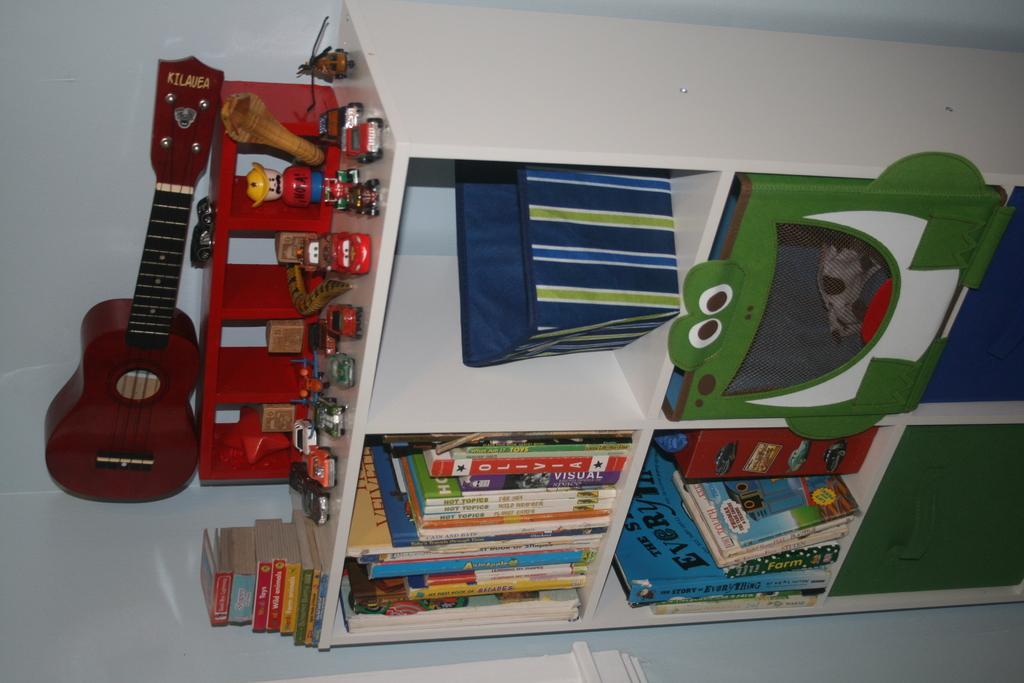How would you summarize this image in a sentence or two? This image is clicked in a room. There is a cupboard and racks in it. Books are kept in the rack. At the top, there are cars , guitar and books. In the background, there is a wall. 